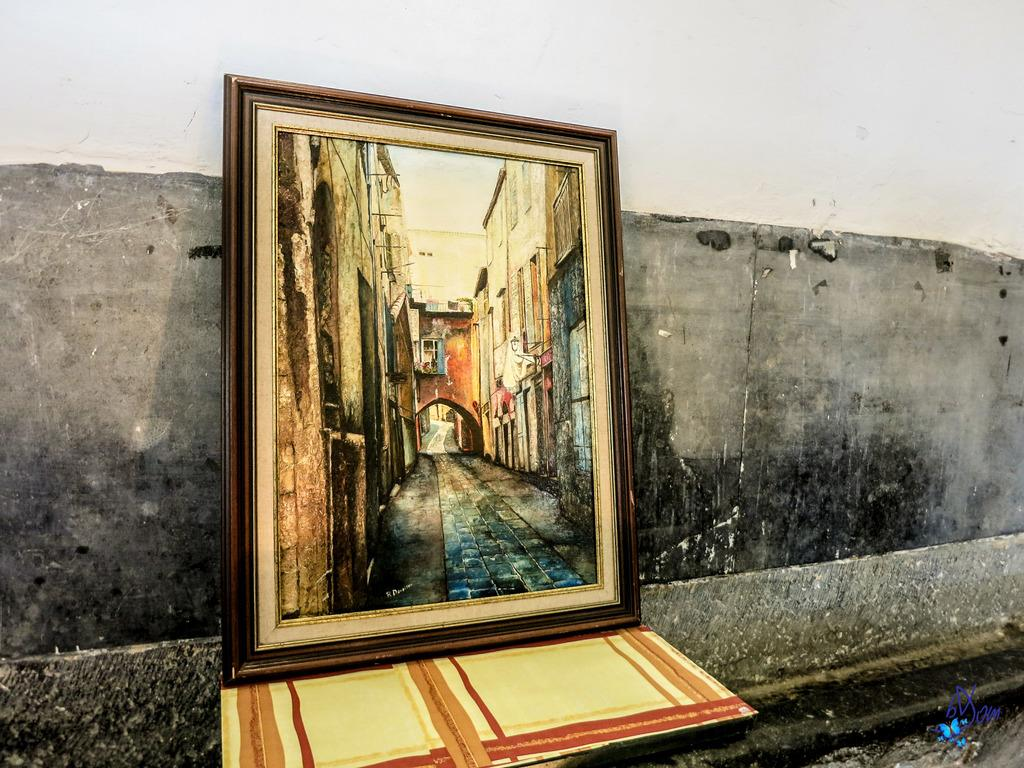What type of structure can be seen in the image? There is a wall in the image. Is there any object attached to the wall? Yes, there is a frame in the image. What is inside the frame? There is a paper visible in the image. Can you identify any specific design or symbol in the image? Yes, there is a logo visible in the image. How does the wall expand in the image? The wall does not expand in the image; it is a static structure. What type of birds can be seen flying near the wall in the image? There are no birds visible in the image. 